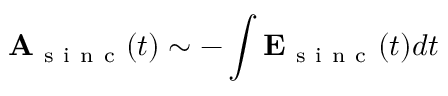Convert formula to latex. <formula><loc_0><loc_0><loc_500><loc_500>A _ { s i n c } ( t ) \sim - \int E _ { s i n c } ( t ) d t</formula> 